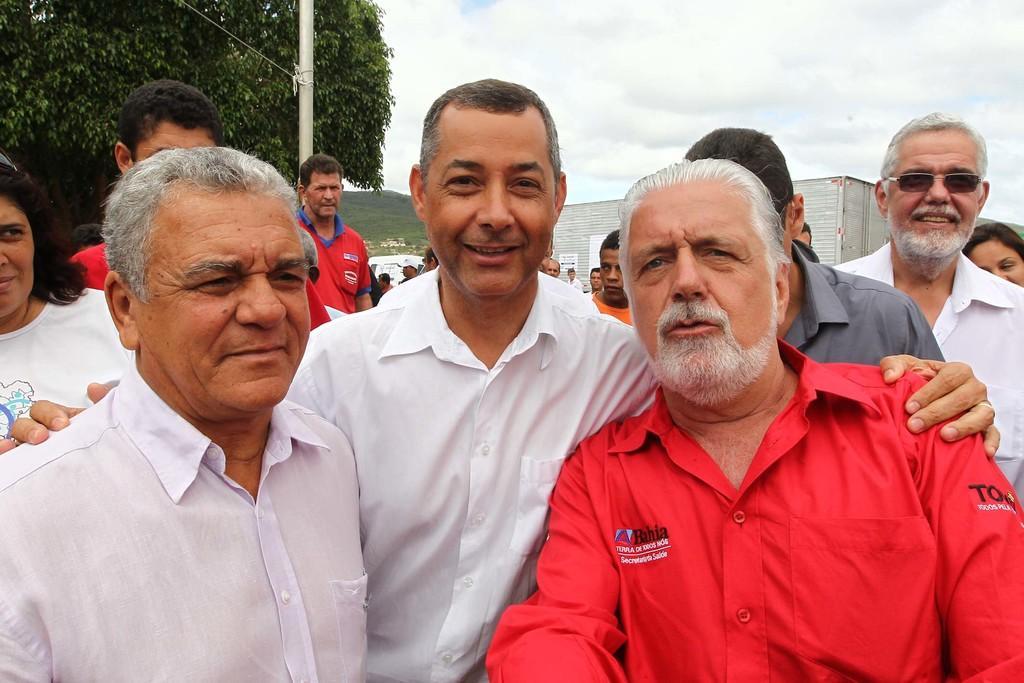Could you give a brief overview of what you see in this image? In this picture we can see some people are taking pictures, back side, we can see some people and some trees, vehicles. 